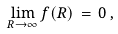<formula> <loc_0><loc_0><loc_500><loc_500>\lim _ { R \to \infty } f ( R ) \, = \, 0 \, ,</formula> 